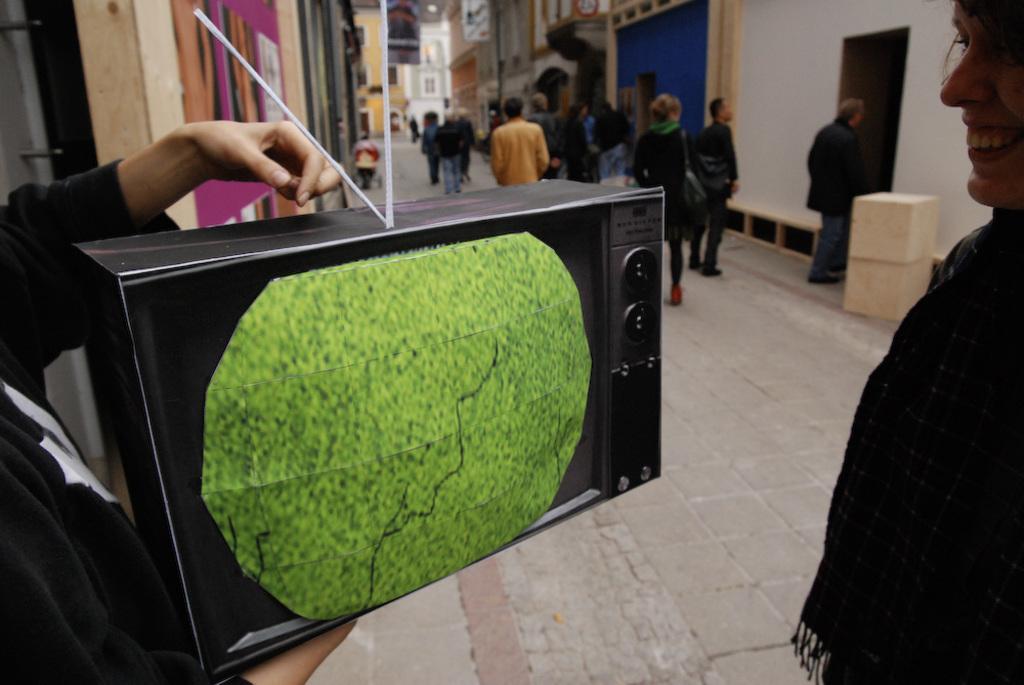How would you summarize this image in a sentence or two? As we can see in the image there is a screen, buildings, boxes and few people walking here and there. 